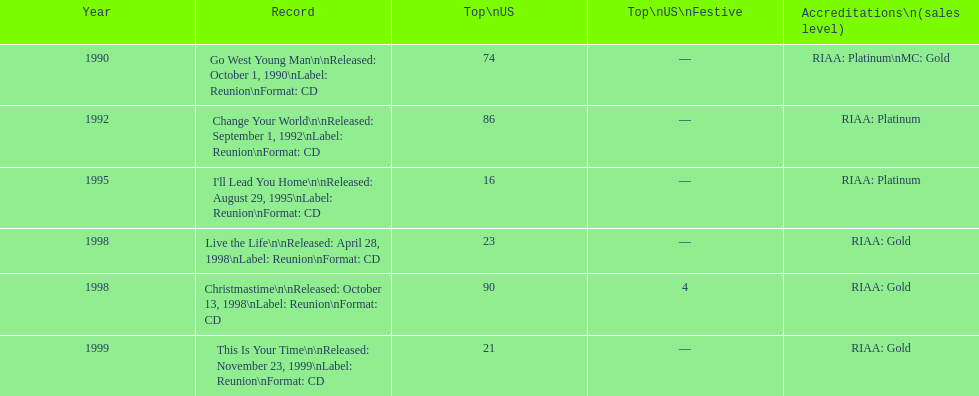What michael w smith album was released before his christmastime album? Live the Life. 